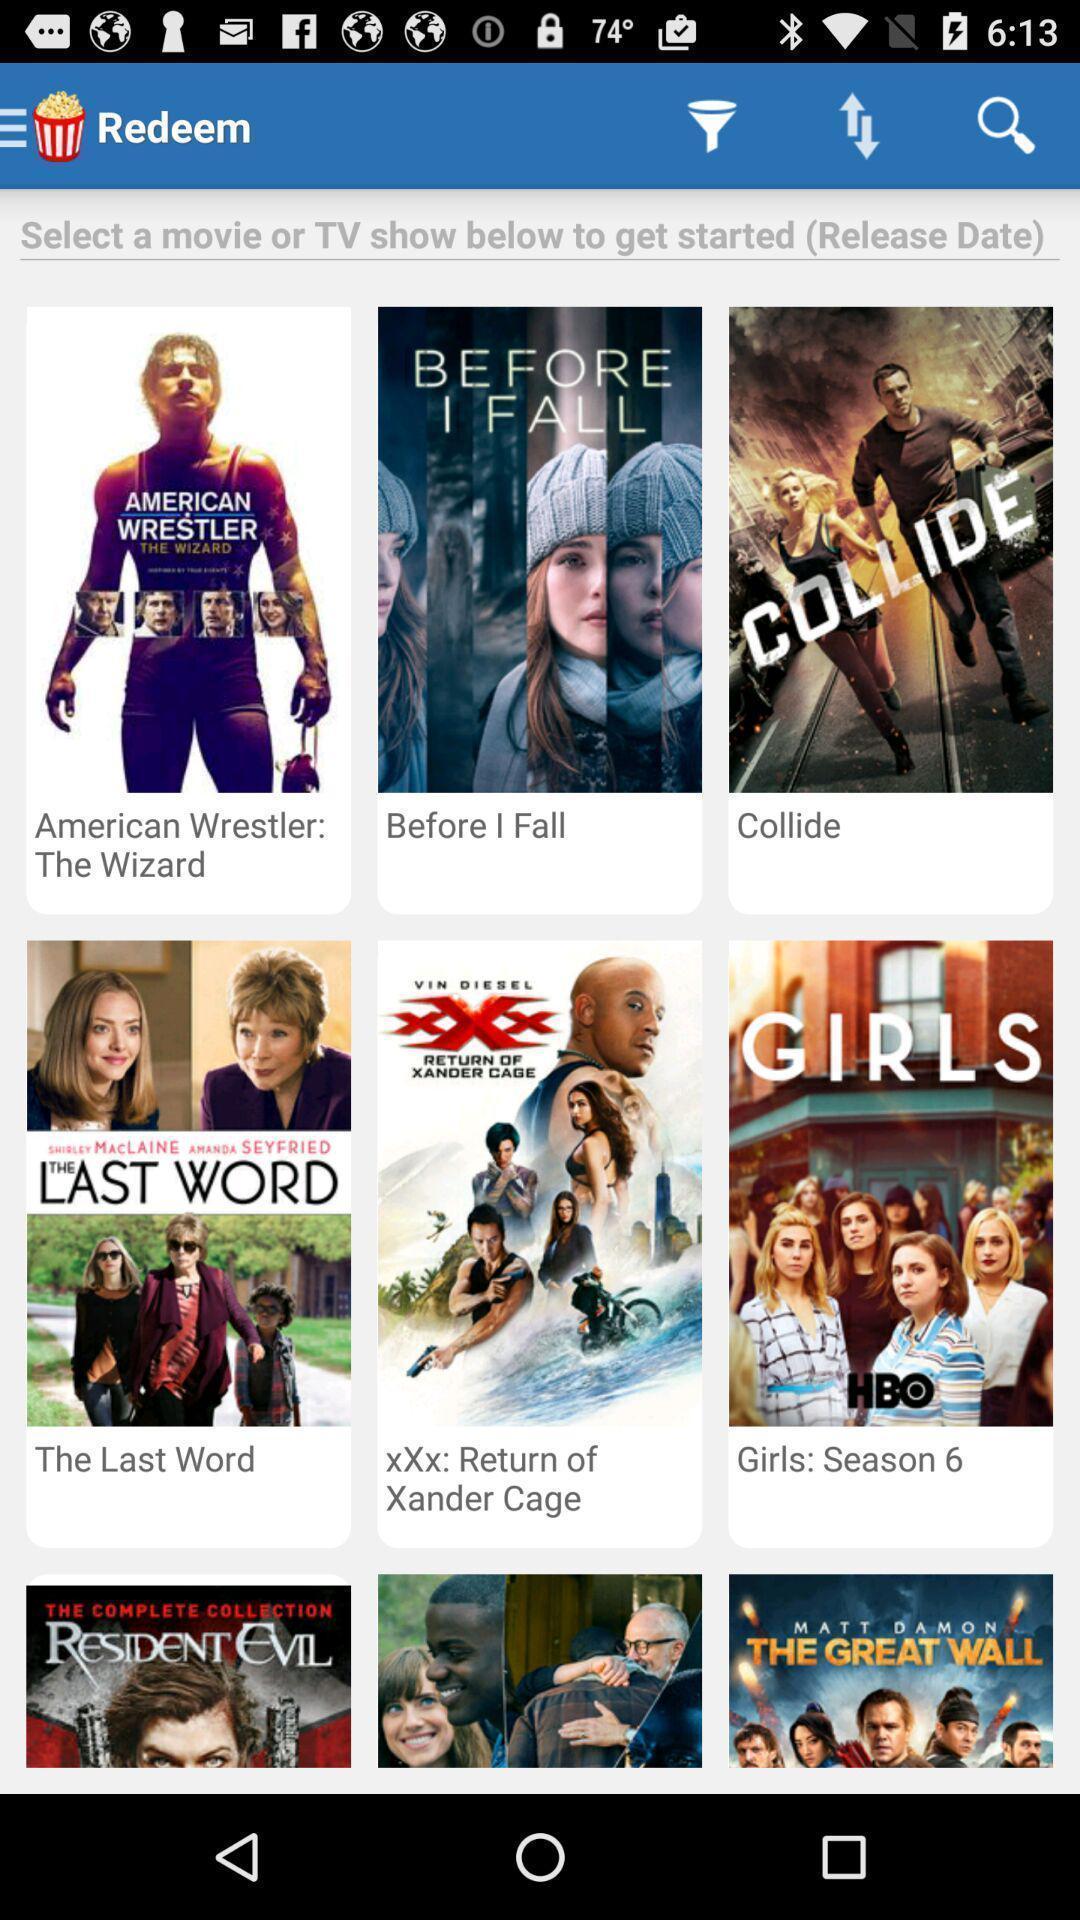Summarize the information in this screenshot. Screen page displaying various categories. 